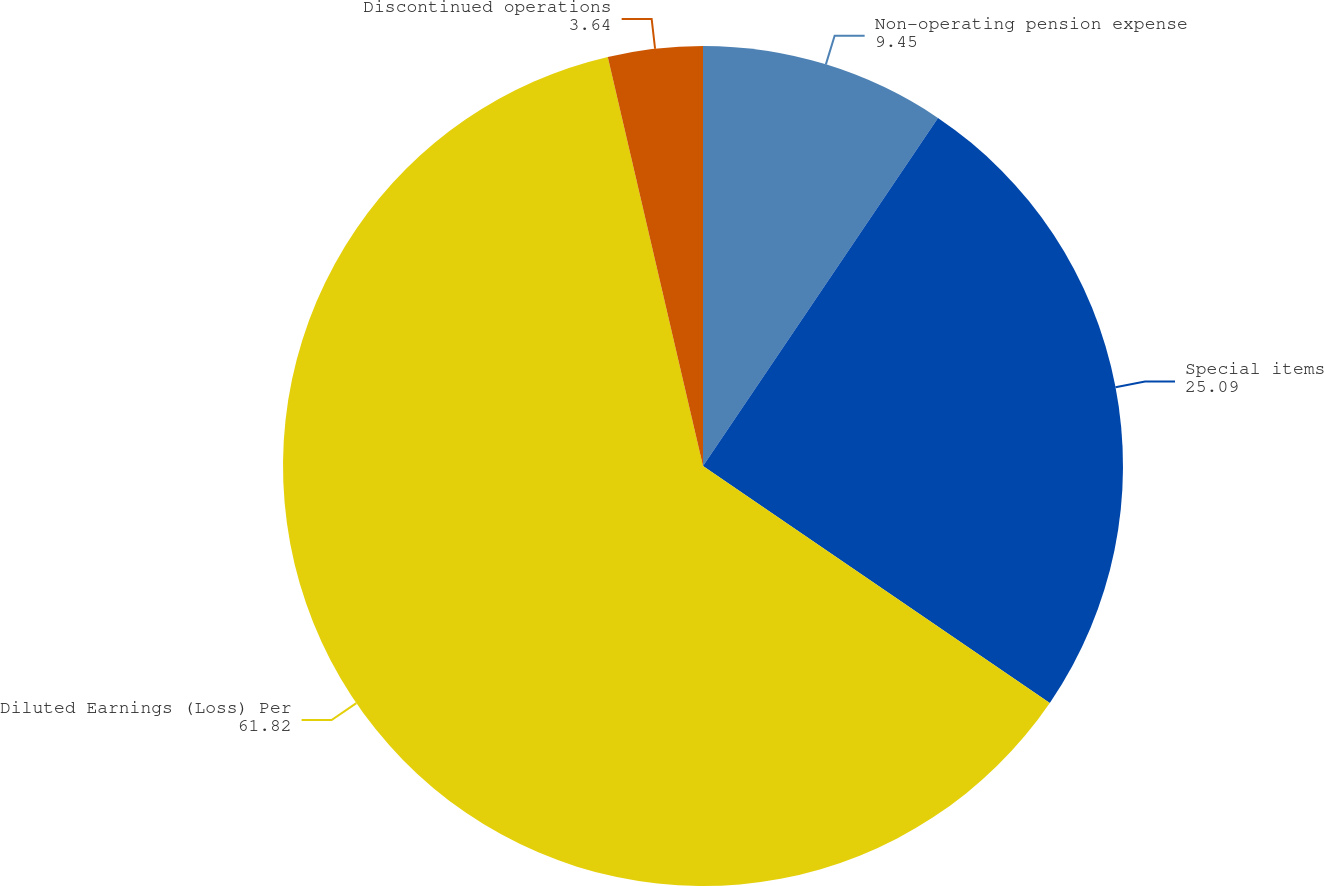Convert chart to OTSL. <chart><loc_0><loc_0><loc_500><loc_500><pie_chart><fcel>Non-operating pension expense<fcel>Special items<fcel>Diluted Earnings (Loss) Per<fcel>Discontinued operations<nl><fcel>9.45%<fcel>25.09%<fcel>61.82%<fcel>3.64%<nl></chart> 